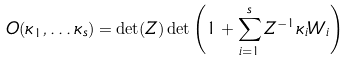Convert formula to latex. <formula><loc_0><loc_0><loc_500><loc_500>O ( \kappa _ { 1 } , \dots \kappa _ { s } ) = \det ( Z ) \det \left ( 1 + \sum _ { i = 1 } ^ { s } Z ^ { - 1 } \kappa _ { i } W _ { i } \right )</formula> 